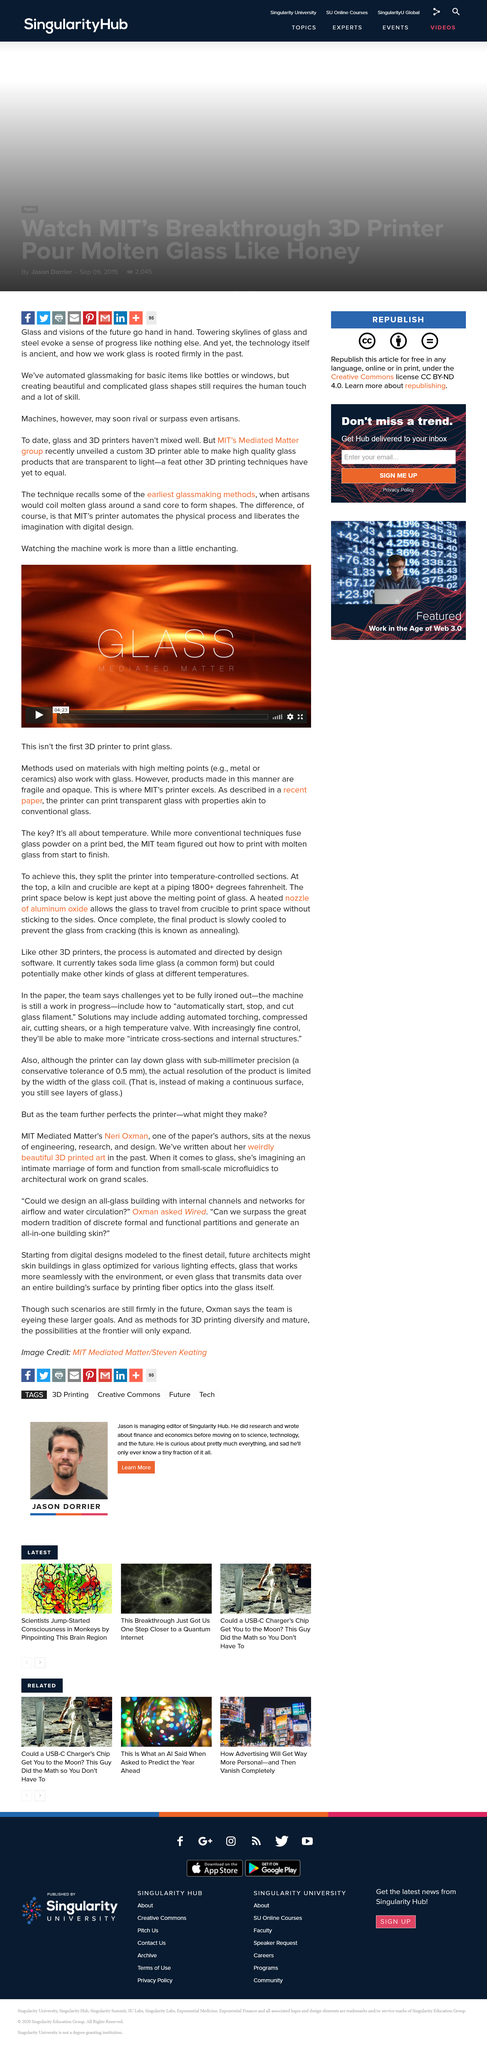Specify some key components in this picture. Automated glassmaking is a reality, despite the fact that glassmaking is not always done by a man using a machine. This new 3D printer is capable of printing glass. The use of glass in the manner described is not considered new, as it has been implemented using some of the earliest methods. 